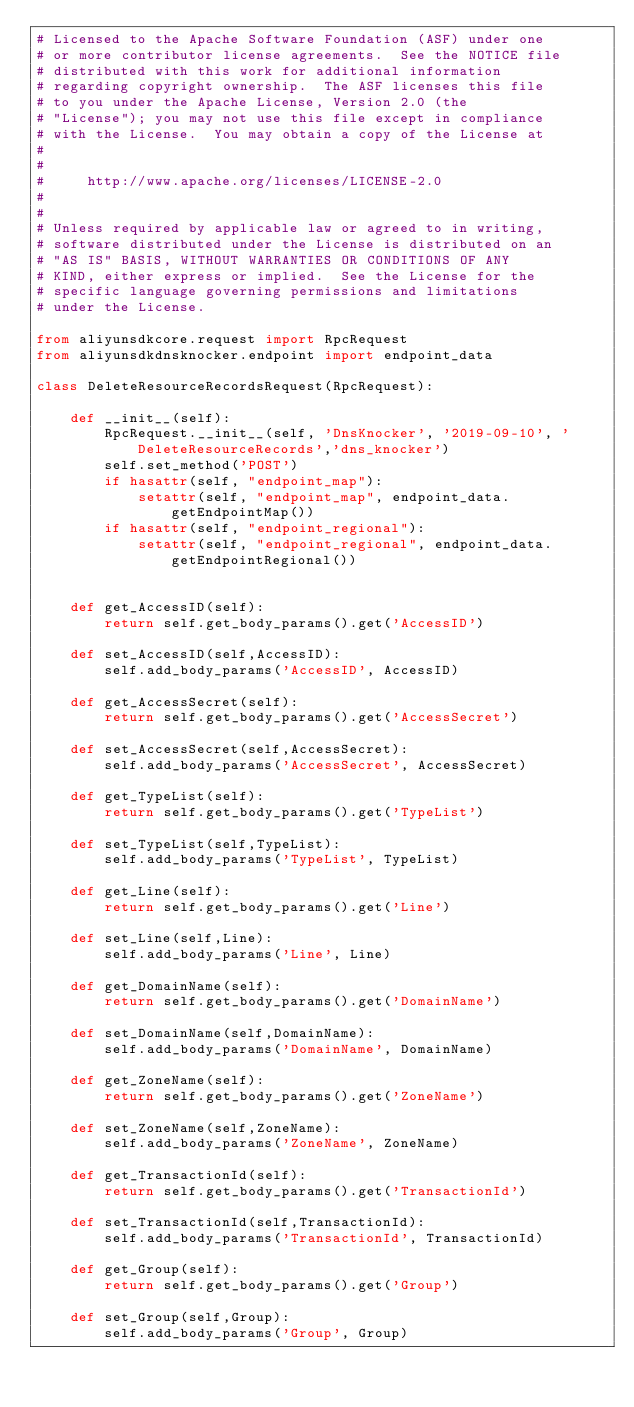Convert code to text. <code><loc_0><loc_0><loc_500><loc_500><_Python_># Licensed to the Apache Software Foundation (ASF) under one
# or more contributor license agreements.  See the NOTICE file
# distributed with this work for additional information
# regarding copyright ownership.  The ASF licenses this file
# to you under the Apache License, Version 2.0 (the
# "License"); you may not use this file except in compliance
# with the License.  You may obtain a copy of the License at
#
#
#     http://www.apache.org/licenses/LICENSE-2.0
#
#
# Unless required by applicable law or agreed to in writing,
# software distributed under the License is distributed on an
# "AS IS" BASIS, WITHOUT WARRANTIES OR CONDITIONS OF ANY
# KIND, either express or implied.  See the License for the
# specific language governing permissions and limitations
# under the License.

from aliyunsdkcore.request import RpcRequest
from aliyunsdkdnsknocker.endpoint import endpoint_data

class DeleteResourceRecordsRequest(RpcRequest):

	def __init__(self):
		RpcRequest.__init__(self, 'DnsKnocker', '2019-09-10', 'DeleteResourceRecords','dns_knocker')
		self.set_method('POST')
		if hasattr(self, "endpoint_map"):
			setattr(self, "endpoint_map", endpoint_data.getEndpointMap())
		if hasattr(self, "endpoint_regional"):
			setattr(self, "endpoint_regional", endpoint_data.getEndpointRegional())


	def get_AccessID(self):
		return self.get_body_params().get('AccessID')

	def set_AccessID(self,AccessID):
		self.add_body_params('AccessID', AccessID)

	def get_AccessSecret(self):
		return self.get_body_params().get('AccessSecret')

	def set_AccessSecret(self,AccessSecret):
		self.add_body_params('AccessSecret', AccessSecret)

	def get_TypeList(self):
		return self.get_body_params().get('TypeList')

	def set_TypeList(self,TypeList):
		self.add_body_params('TypeList', TypeList)

	def get_Line(self):
		return self.get_body_params().get('Line')

	def set_Line(self,Line):
		self.add_body_params('Line', Line)

	def get_DomainName(self):
		return self.get_body_params().get('DomainName')

	def set_DomainName(self,DomainName):
		self.add_body_params('DomainName', DomainName)

	def get_ZoneName(self):
		return self.get_body_params().get('ZoneName')

	def set_ZoneName(self,ZoneName):
		self.add_body_params('ZoneName', ZoneName)

	def get_TransactionId(self):
		return self.get_body_params().get('TransactionId')

	def set_TransactionId(self,TransactionId):
		self.add_body_params('TransactionId', TransactionId)

	def get_Group(self):
		return self.get_body_params().get('Group')

	def set_Group(self,Group):
		self.add_body_params('Group', Group)</code> 